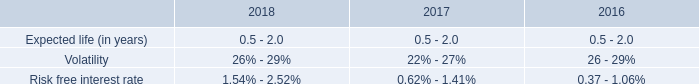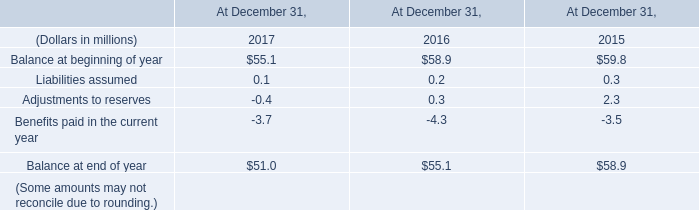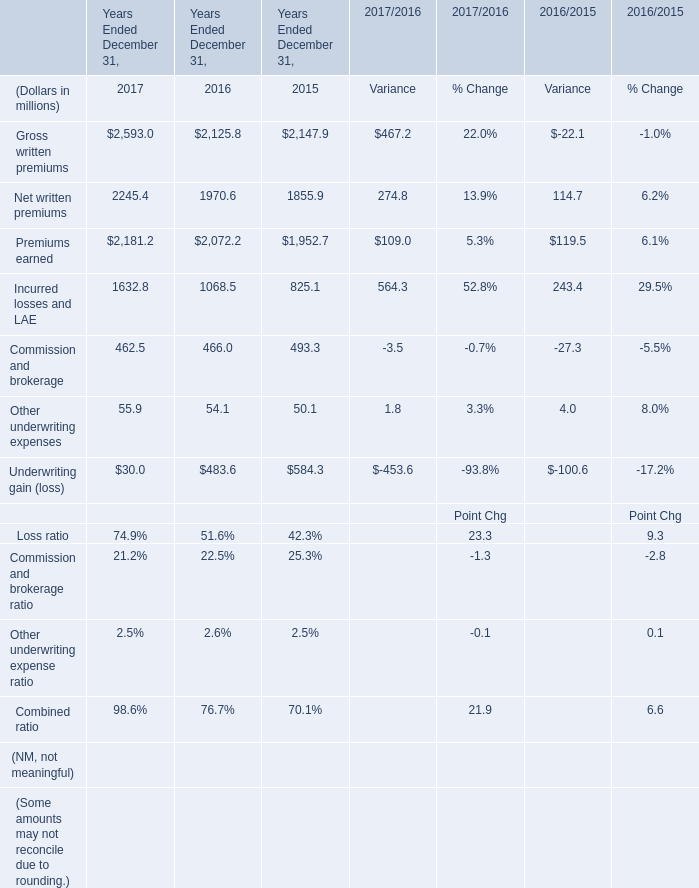What is the sum of the year end December 31 in the years where Commission and brokerage is greater than 490? (in million) 
Computations: ((((((2147.9 + 1855.9) + 1952.7) + 825.1) + 493.3) + 50.1) + 584.3)
Answer: 7909.3. Which year is Commission and brokerage greater than 490 ? 
Answer: 2015. 